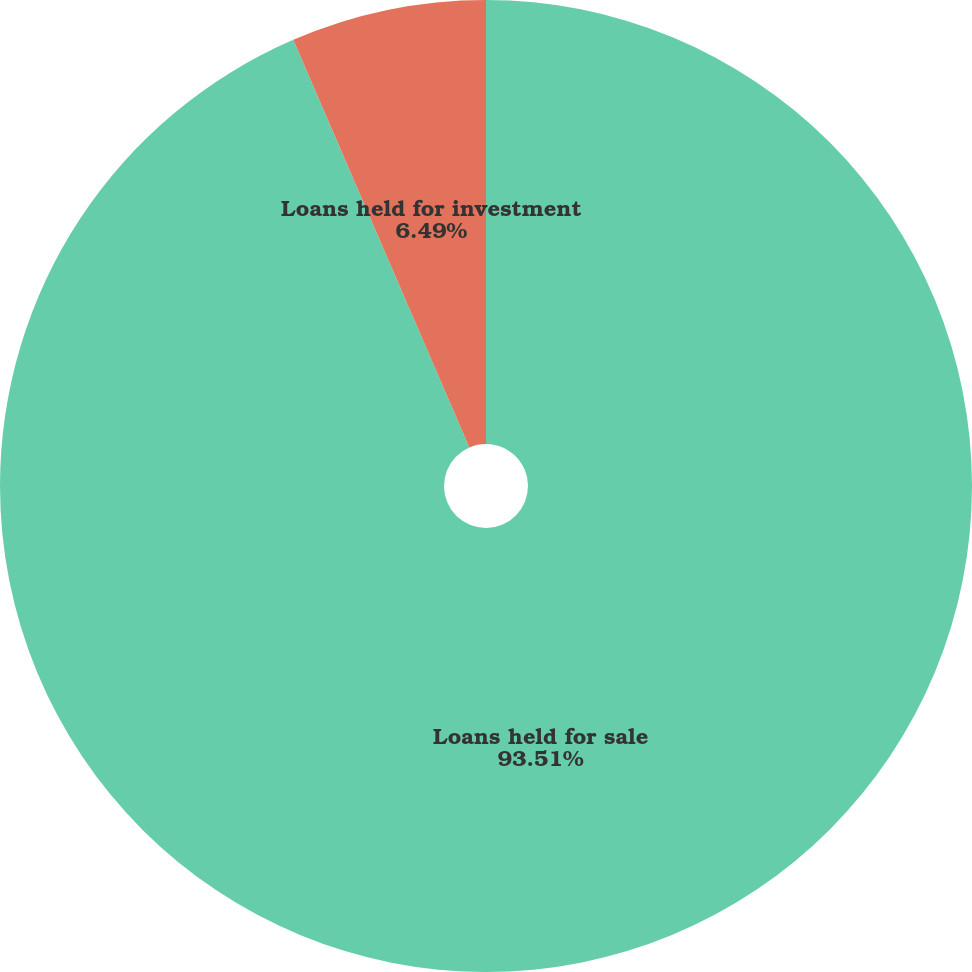Convert chart. <chart><loc_0><loc_0><loc_500><loc_500><pie_chart><fcel>Loans held for sale<fcel>Loans held for investment<nl><fcel>93.51%<fcel>6.49%<nl></chart> 